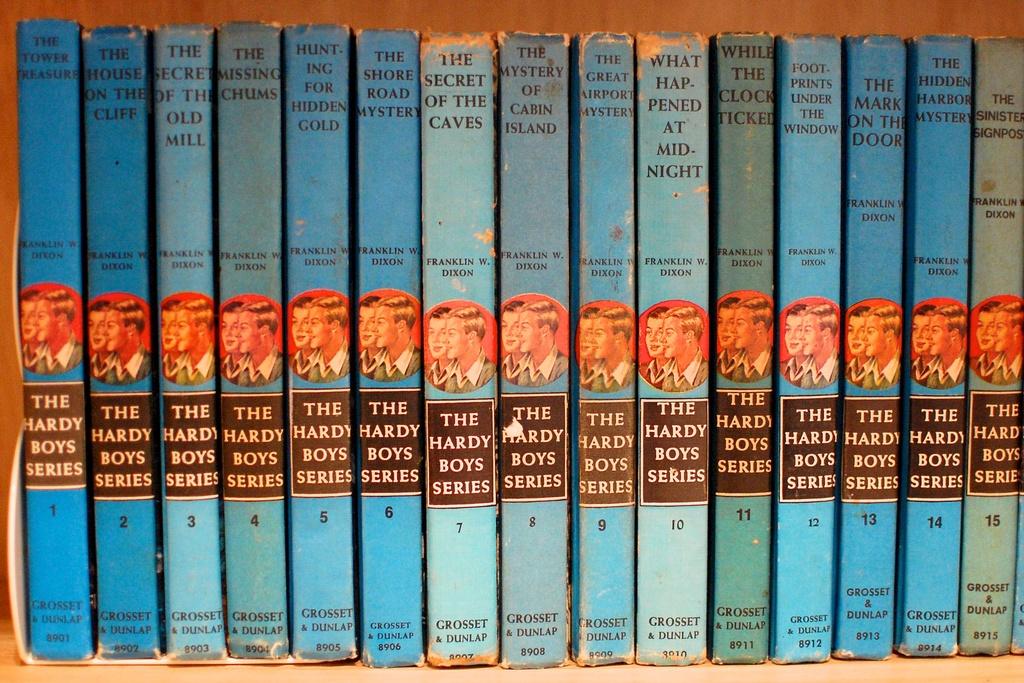What series of books is this?
Offer a very short reply. The hardy boys. What the title of the books shown?
Provide a succinct answer. The hardy boys series. 